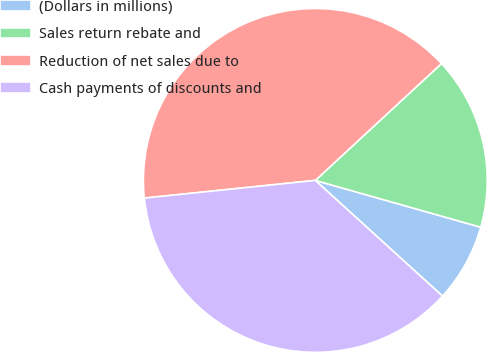Convert chart to OTSL. <chart><loc_0><loc_0><loc_500><loc_500><pie_chart><fcel>(Dollars in millions)<fcel>Sales return rebate and<fcel>Reduction of net sales due to<fcel>Cash payments of discounts and<nl><fcel>7.36%<fcel>16.28%<fcel>39.75%<fcel>36.61%<nl></chart> 